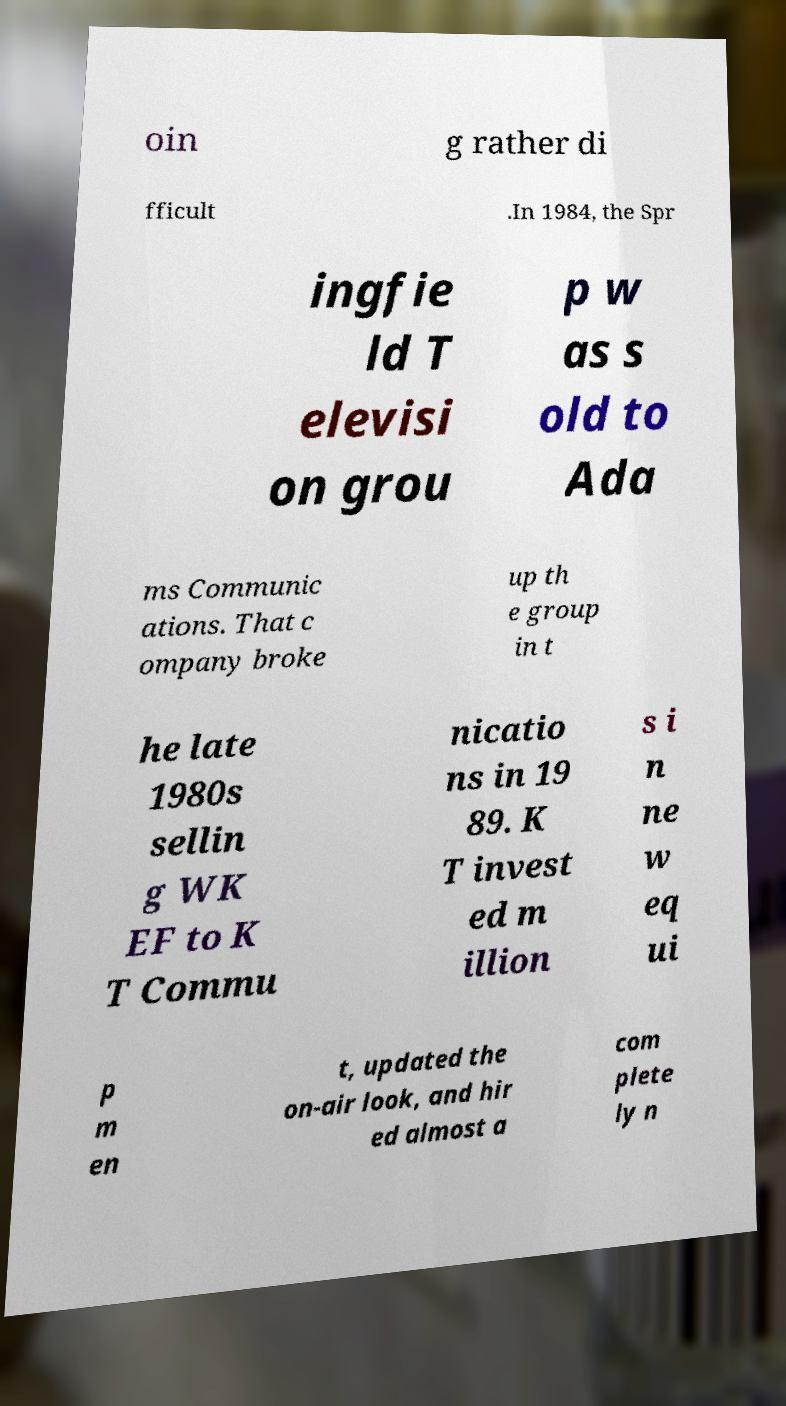Could you assist in decoding the text presented in this image and type it out clearly? oin g rather di fficult .In 1984, the Spr ingfie ld T elevisi on grou p w as s old to Ada ms Communic ations. That c ompany broke up th e group in t he late 1980s sellin g WK EF to K T Commu nicatio ns in 19 89. K T invest ed m illion s i n ne w eq ui p m en t, updated the on-air look, and hir ed almost a com plete ly n 